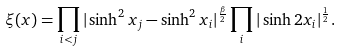Convert formula to latex. <formula><loc_0><loc_0><loc_500><loc_500>\xi ( x ) = \prod _ { i < j } | \sinh ^ { 2 } x _ { j } - \sinh ^ { 2 } x _ { i } | ^ { \frac { \beta } { 2 } } \prod _ { i } | \sinh 2 x _ { i } | ^ { \frac { 1 } { 2 } } .</formula> 